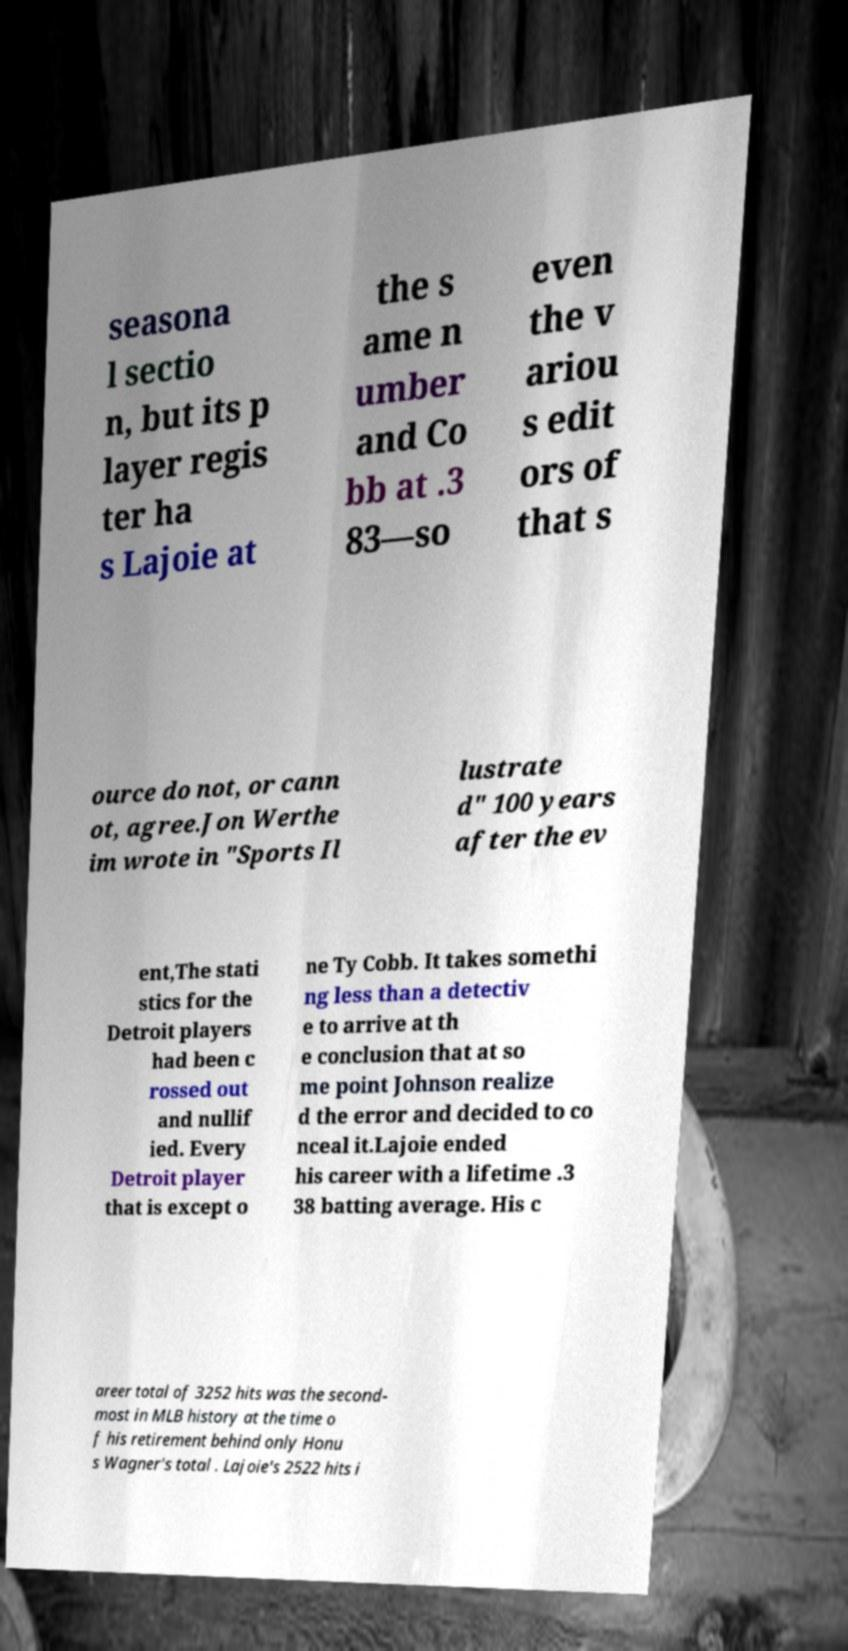There's text embedded in this image that I need extracted. Can you transcribe it verbatim? seasona l sectio n, but its p layer regis ter ha s Lajoie at the s ame n umber and Co bb at .3 83—so even the v ariou s edit ors of that s ource do not, or cann ot, agree.Jon Werthe im wrote in "Sports Il lustrate d" 100 years after the ev ent,The stati stics for the Detroit players had been c rossed out and nullif ied. Every Detroit player that is except o ne Ty Cobb. It takes somethi ng less than a detectiv e to arrive at th e conclusion that at so me point Johnson realize d the error and decided to co nceal it.Lajoie ended his career with a lifetime .3 38 batting average. His c areer total of 3252 hits was the second- most in MLB history at the time o f his retirement behind only Honu s Wagner's total . Lajoie's 2522 hits i 